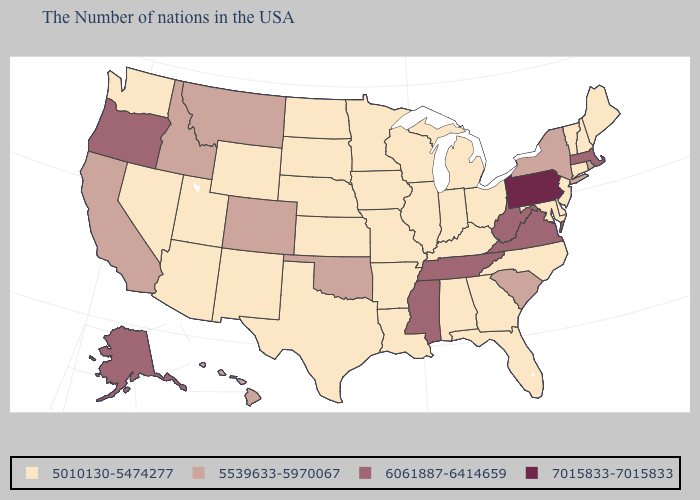What is the value of North Carolina?
Quick response, please. 5010130-5474277. Does the map have missing data?
Short answer required. No. Name the states that have a value in the range 5010130-5474277?
Short answer required. Maine, New Hampshire, Vermont, Connecticut, New Jersey, Delaware, Maryland, North Carolina, Ohio, Florida, Georgia, Michigan, Kentucky, Indiana, Alabama, Wisconsin, Illinois, Louisiana, Missouri, Arkansas, Minnesota, Iowa, Kansas, Nebraska, Texas, South Dakota, North Dakota, Wyoming, New Mexico, Utah, Arizona, Nevada, Washington. What is the value of Iowa?
Write a very short answer. 5010130-5474277. Which states hav the highest value in the Northeast?
Short answer required. Pennsylvania. What is the value of Hawaii?
Quick response, please. 5539633-5970067. What is the value of Louisiana?
Concise answer only. 5010130-5474277. What is the highest value in the USA?
Quick response, please. 7015833-7015833. What is the value of Oregon?
Give a very brief answer. 6061887-6414659. What is the value of Indiana?
Give a very brief answer. 5010130-5474277. What is the value of Michigan?
Quick response, please. 5010130-5474277. Does Kansas have the same value as Michigan?
Quick response, please. Yes. What is the highest value in the USA?
Give a very brief answer. 7015833-7015833. What is the highest value in the USA?
Short answer required. 7015833-7015833. 